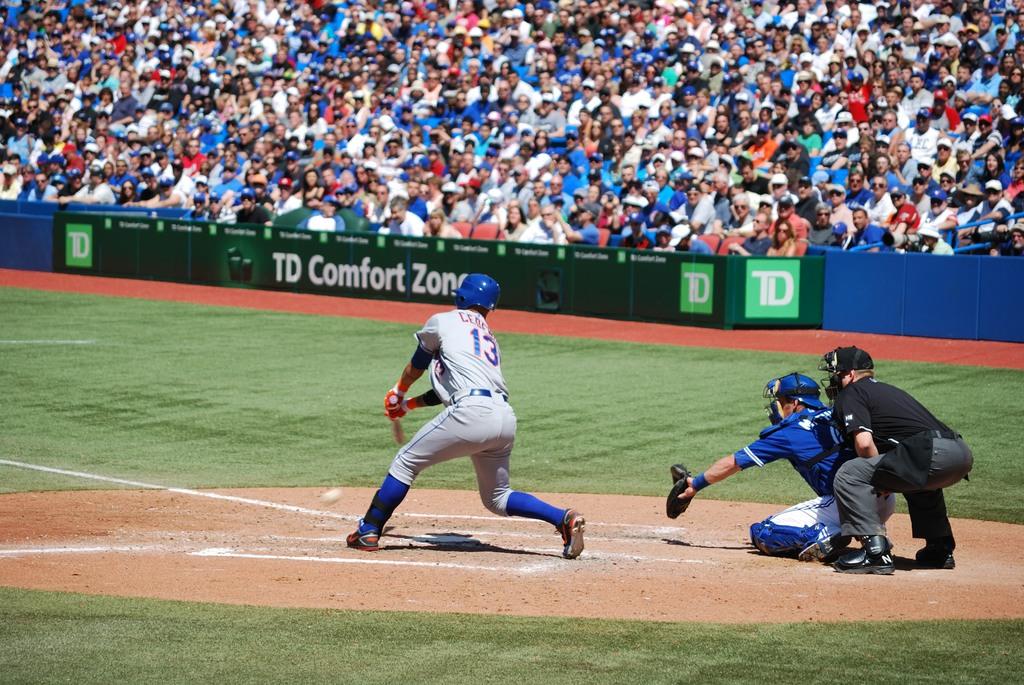What company is advertising on the green banner?
Provide a short and direct response. Td comfort zone. 